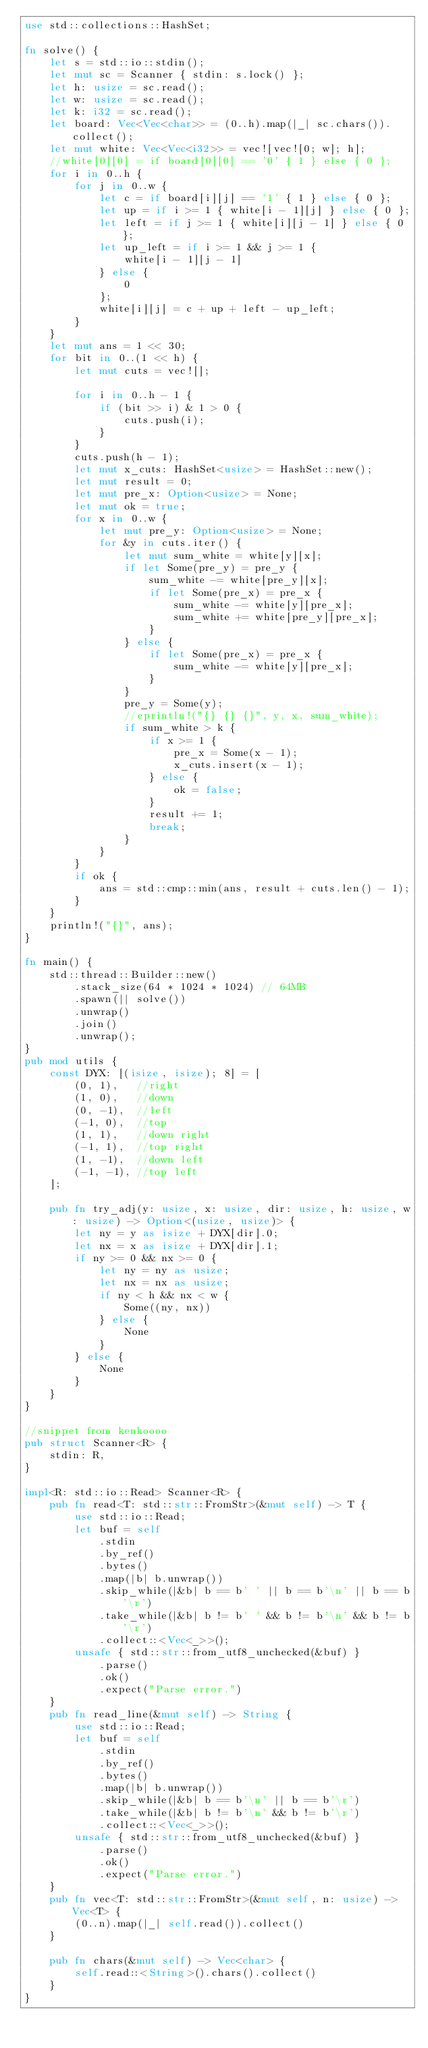<code> <loc_0><loc_0><loc_500><loc_500><_Rust_>use std::collections::HashSet;

fn solve() {
    let s = std::io::stdin();
    let mut sc = Scanner { stdin: s.lock() };
    let h: usize = sc.read();
    let w: usize = sc.read();
    let k: i32 = sc.read();
    let board: Vec<Vec<char>> = (0..h).map(|_| sc.chars()).collect();
    let mut white: Vec<Vec<i32>> = vec![vec![0; w]; h];
    //white[0][0] = if board[0][0] == '0' { 1 } else { 0 };
    for i in 0..h {
        for j in 0..w {
            let c = if board[i][j] == '1' { 1 } else { 0 };
            let up = if i >= 1 { white[i - 1][j] } else { 0 };
            let left = if j >= 1 { white[i][j - 1] } else { 0 };
            let up_left = if i >= 1 && j >= 1 {
                white[i - 1][j - 1]
            } else {
                0
            };
            white[i][j] = c + up + left - up_left;
        }
    }
    let mut ans = 1 << 30;
    for bit in 0..(1 << h) {
        let mut cuts = vec![];

        for i in 0..h - 1 {
            if (bit >> i) & 1 > 0 {
                cuts.push(i);
            }
        }
        cuts.push(h - 1);
        let mut x_cuts: HashSet<usize> = HashSet::new();
        let mut result = 0;
        let mut pre_x: Option<usize> = None;
        let mut ok = true;
        for x in 0..w {
            let mut pre_y: Option<usize> = None;
            for &y in cuts.iter() {
                let mut sum_white = white[y][x];
                if let Some(pre_y) = pre_y {
                    sum_white -= white[pre_y][x];
                    if let Some(pre_x) = pre_x {
                        sum_white -= white[y][pre_x];
                        sum_white += white[pre_y][pre_x];
                    }
                } else {
                    if let Some(pre_x) = pre_x {
                        sum_white -= white[y][pre_x];
                    }
                }
                pre_y = Some(y);
                //eprintln!("{} {} {}", y, x, sum_white);
                if sum_white > k {
                    if x >= 1 {
                        pre_x = Some(x - 1);
                        x_cuts.insert(x - 1);
                    } else {
                        ok = false;
                    }
                    result += 1;
                    break;
                }
            }
        }
        if ok {
            ans = std::cmp::min(ans, result + cuts.len() - 1);
        }
    }
    println!("{}", ans);
}

fn main() {
    std::thread::Builder::new()
        .stack_size(64 * 1024 * 1024) // 64MB
        .spawn(|| solve())
        .unwrap()
        .join()
        .unwrap();
}
pub mod utils {
    const DYX: [(isize, isize); 8] = [
        (0, 1),   //right
        (1, 0),   //down
        (0, -1),  //left
        (-1, 0),  //top
        (1, 1),   //down right
        (-1, 1),  //top right
        (1, -1),  //down left
        (-1, -1), //top left
    ];

    pub fn try_adj(y: usize, x: usize, dir: usize, h: usize, w: usize) -> Option<(usize, usize)> {
        let ny = y as isize + DYX[dir].0;
        let nx = x as isize + DYX[dir].1;
        if ny >= 0 && nx >= 0 {
            let ny = ny as usize;
            let nx = nx as usize;
            if ny < h && nx < w {
                Some((ny, nx))
            } else {
                None
            }
        } else {
            None
        }
    }
}

//snippet from kenkoooo
pub struct Scanner<R> {
    stdin: R,
}

impl<R: std::io::Read> Scanner<R> {
    pub fn read<T: std::str::FromStr>(&mut self) -> T {
        use std::io::Read;
        let buf = self
            .stdin
            .by_ref()
            .bytes()
            .map(|b| b.unwrap())
            .skip_while(|&b| b == b' ' || b == b'\n' || b == b'\r')
            .take_while(|&b| b != b' ' && b != b'\n' && b != b'\r')
            .collect::<Vec<_>>();
        unsafe { std::str::from_utf8_unchecked(&buf) }
            .parse()
            .ok()
            .expect("Parse error.")
    }
    pub fn read_line(&mut self) -> String {
        use std::io::Read;
        let buf = self
            .stdin
            .by_ref()
            .bytes()
            .map(|b| b.unwrap())
            .skip_while(|&b| b == b'\n' || b == b'\r')
            .take_while(|&b| b != b'\n' && b != b'\r')
            .collect::<Vec<_>>();
        unsafe { std::str::from_utf8_unchecked(&buf) }
            .parse()
            .ok()
            .expect("Parse error.")
    }
    pub fn vec<T: std::str::FromStr>(&mut self, n: usize) -> Vec<T> {
        (0..n).map(|_| self.read()).collect()
    }

    pub fn chars(&mut self) -> Vec<char> {
        self.read::<String>().chars().collect()
    }
}
</code> 